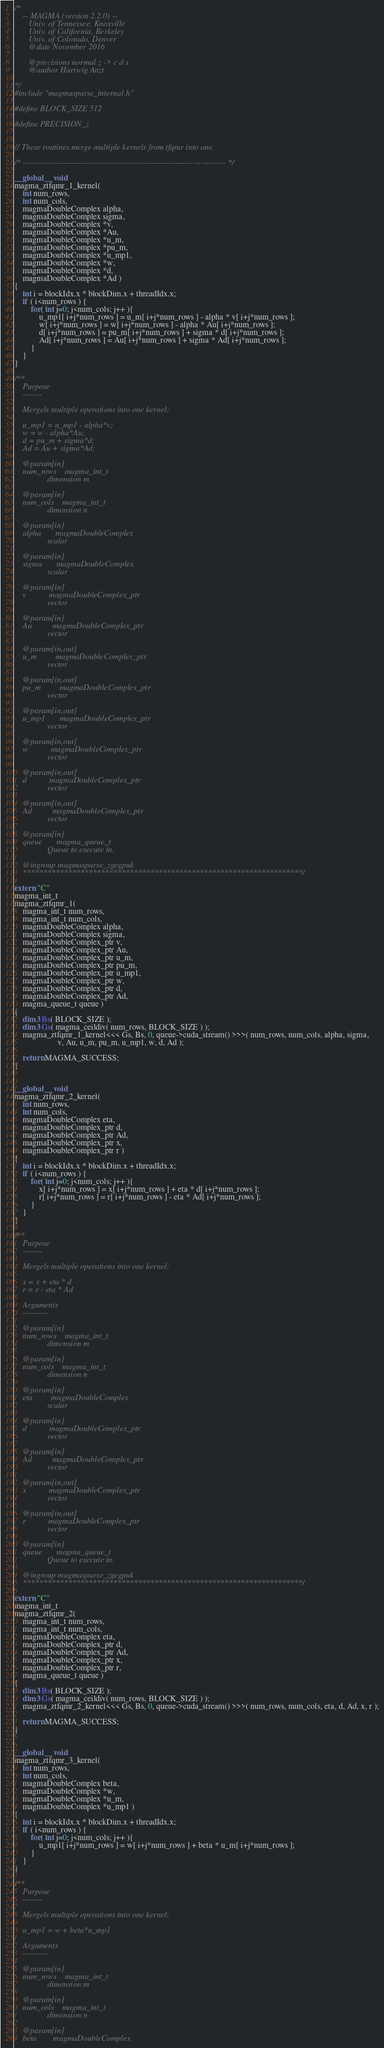Convert code to text. <code><loc_0><loc_0><loc_500><loc_500><_Cuda_>/*
    -- MAGMA (version 2.2.0) --
       Univ. of Tennessee, Knoxville
       Univ. of California, Berkeley
       Univ. of Colorado, Denver
       @date November 2016

       @precisions normal z -> c d s
       @author Hartwig Anzt

*/
#include "magmasparse_internal.h"

#define BLOCK_SIZE 512

#define PRECISION_z


// These routines merge multiple kernels from tfqmr into one.

/* -------------------------------------------------------------------------- */

__global__ void
magma_ztfqmr_1_kernel(  
    int num_rows, 
    int num_cols, 
    magmaDoubleComplex alpha,
    magmaDoubleComplex sigma,
    magmaDoubleComplex *v, 
    magmaDoubleComplex *Au,
    magmaDoubleComplex *u_m,
    magmaDoubleComplex *pu_m,
    magmaDoubleComplex *u_mp1,
    magmaDoubleComplex *w, 
    magmaDoubleComplex *d,
    magmaDoubleComplex *Ad )
{
    int i = blockIdx.x * blockDim.x + threadIdx.x;
    if ( i<num_rows ) {
        for( int j=0; j<num_cols; j++ ){
            u_mp1[ i+j*num_rows ] = u_m[ i+j*num_rows ] - alpha * v[ i+j*num_rows ];
            w[ i+j*num_rows ] = w[ i+j*num_rows ] - alpha * Au[ i+j*num_rows ];
            d[ i+j*num_rows ] = pu_m[ i+j*num_rows ] + sigma * d[ i+j*num_rows ];
            Ad[ i+j*num_rows ] = Au[ i+j*num_rows ] + sigma * Ad[ i+j*num_rows ];
        }
    }
}

/**
    Purpose
    -------

    Mergels multiple operations into one kernel:

    u_mp1 = u_mp1 - alpha*v;
    w = w - alpha*Au;
    d = pu_m + sigma*d;
    Ad = Au + sigma*Ad;
    
    @param[in]
    num_rows    magma_int_t
                dimension m
                
    @param[in]
    num_cols    magma_int_t
                dimension n
                
    @param[in]
    alpha       magmaDoubleComplex
                scalar
                
    @param[in]
    sigma       magmaDoubleComplex
                scalar
                
    @param[in]
    v           magmaDoubleComplex_ptr 
                vector
                
    @param[in]
    Au          magmaDoubleComplex_ptr 
                vector
                
    @param[in,out]
    u_m         magmaDoubleComplex_ptr 
                vector
                
    @param[in,out]
    pu_m         magmaDoubleComplex_ptr 
                vector
                
    @param[in,out]
    u_mp1       magmaDoubleComplex_ptr 
                vector

    @param[in,out]
    w           magmaDoubleComplex_ptr 
                vector
                
    @param[in,out]
    d           magmaDoubleComplex_ptr 
                vector
                
    @param[in,out]
    Ad          magmaDoubleComplex_ptr 
                vector

    @param[in]
    queue       magma_queue_t
                Queue to execute in.

    @ingroup magmasparse_zgegpuk
    ********************************************************************/

extern "C" 
magma_int_t
magma_ztfqmr_1(  
    magma_int_t num_rows, 
    magma_int_t num_cols, 
    magmaDoubleComplex alpha,
    magmaDoubleComplex sigma,
    magmaDoubleComplex_ptr v, 
    magmaDoubleComplex_ptr Au,
    magmaDoubleComplex_ptr u_m,
    magmaDoubleComplex_ptr pu_m,
    magmaDoubleComplex_ptr u_mp1,
    magmaDoubleComplex_ptr w, 
    magmaDoubleComplex_ptr d,
    magmaDoubleComplex_ptr Ad,
    magma_queue_t queue )
{
    dim3 Bs( BLOCK_SIZE );
    dim3 Gs( magma_ceildiv( num_rows, BLOCK_SIZE ) );
    magma_ztfqmr_1_kernel<<< Gs, Bs, 0, queue->cuda_stream() >>>( num_rows, num_cols, alpha, sigma,
                     v, Au, u_m, pu_m, u_mp1, w, d, Ad );

    return MAGMA_SUCCESS;
}


__global__ void
magma_ztfqmr_2_kernel(  
    int num_rows,
    int num_cols,
    magmaDoubleComplex eta,
    magmaDoubleComplex_ptr d,
    magmaDoubleComplex_ptr Ad,
    magmaDoubleComplex_ptr x, 
    magmaDoubleComplex_ptr r )
{
    int i = blockIdx.x * blockDim.x + threadIdx.x;
    if ( i<num_rows ) {
        for( int j=0; j<num_cols; j++ ){
            x[ i+j*num_rows ] = x[ i+j*num_rows ] + eta * d[ i+j*num_rows ];
            r[ i+j*num_rows ] = r[ i+j*num_rows ] - eta * Ad[ i+j*num_rows ];
        }
    }
}

/**
    Purpose
    -------

    Mergels multiple operations into one kernel:

    x = x + eta * d
    r = r - eta * Ad

    Arguments
    ---------

    @param[in]
    num_rows    magma_int_t
                dimension m
                
    @param[in]
    num_cols    magma_int_t
                dimension n
                
    @param[in]
    eta         magmaDoubleComplex
                scalar
                
    @param[in]
    d           magmaDoubleComplex_ptr 
                vector
                
    @param[in]
    Ad          magmaDoubleComplex_ptr 
                vector

    @param[in,out]
    x           magmaDoubleComplex_ptr 
                vector
                
    @param[in,out]
    r           magmaDoubleComplex_ptr 
                vector

    @param[in]
    queue       magma_queue_t
                Queue to execute in.

    @ingroup magmasparse_zgegpuk
    ********************************************************************/

extern "C" 
magma_int_t
magma_ztfqmr_2(  
    magma_int_t num_rows, 
    magma_int_t num_cols, 
    magmaDoubleComplex eta,
    magmaDoubleComplex_ptr d,
    magmaDoubleComplex_ptr Ad,
    magmaDoubleComplex_ptr x, 
    magmaDoubleComplex_ptr r, 
    magma_queue_t queue )
{
    dim3 Bs( BLOCK_SIZE );
    dim3 Gs( magma_ceildiv( num_rows, BLOCK_SIZE ) );
    magma_ztfqmr_2_kernel<<< Gs, Bs, 0, queue->cuda_stream() >>>( num_rows, num_cols, eta, d, Ad, x, r );

    return MAGMA_SUCCESS;
}


__global__ void
magma_ztfqmr_3_kernel(  
    int num_rows,
    int num_cols,
    magmaDoubleComplex beta,
    magmaDoubleComplex *w,
    magmaDoubleComplex *u_m,
    magmaDoubleComplex *u_mp1 )
{
    int i = blockIdx.x * blockDim.x + threadIdx.x;
    if ( i<num_rows ) {
        for( int j=0; j<num_cols; j++ ){
            u_mp1[ i+j*num_rows ] = w[ i+j*num_rows ] + beta * u_m[ i+j*num_rows ];
        }
    }
}

/**
    Purpose
    -------

    Mergels multiple operations into one kernel:

    u_mp1 = w + beta*u_mp1

    Arguments
    ---------

    @param[in]
    num_rows    magma_int_t
                dimension m
                
    @param[in]
    num_cols    magma_int_t
                dimension n
                
    @param[in]
    beta        magmaDoubleComplex</code> 